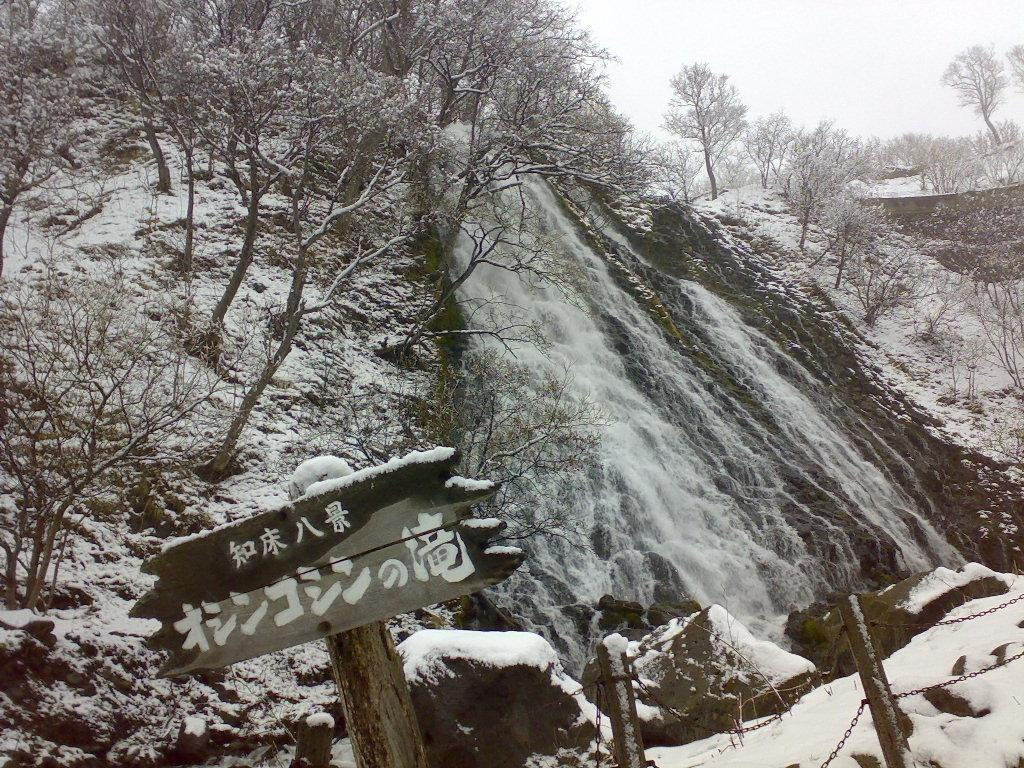What is the main structure in the image? There is a wooden pole with a board in the image. What is located near the wooden pole? There is a fence beside the wooden pole. What type of natural environment is visible in the image? Trees are present in the image. What is the weather condition in the image? There is snow visible in the image, indicating a cold climate. What can be seen in the sky in the image? The sky is visible in the image. What type of debt is being discussed in the image? There is no mention of debt or any discussion in the image; it primarily features a wooden pole with a board, a fence, trees, snow, and the sky. 